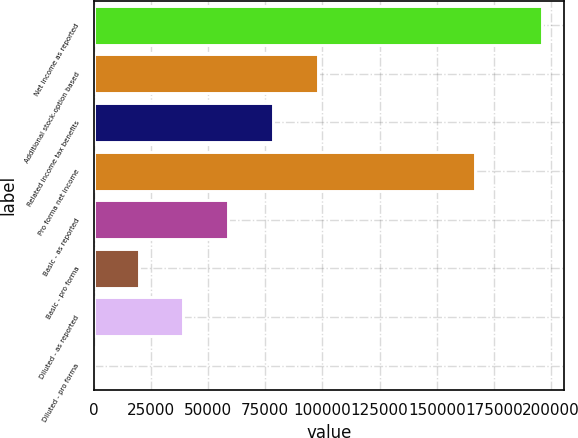<chart> <loc_0><loc_0><loc_500><loc_500><bar_chart><fcel>Net income as reported<fcel>Additional stock-option based<fcel>Related income tax benefits<fcel>Pro forma net income<fcel>Basic - as reported<fcel>Basic - pro forma<fcel>Diluted - as reported<fcel>Diluted - pro forma<nl><fcel>195868<fcel>97934.6<fcel>78348<fcel>166651<fcel>58761.3<fcel>19588<fcel>39174.6<fcel>1.3<nl></chart> 